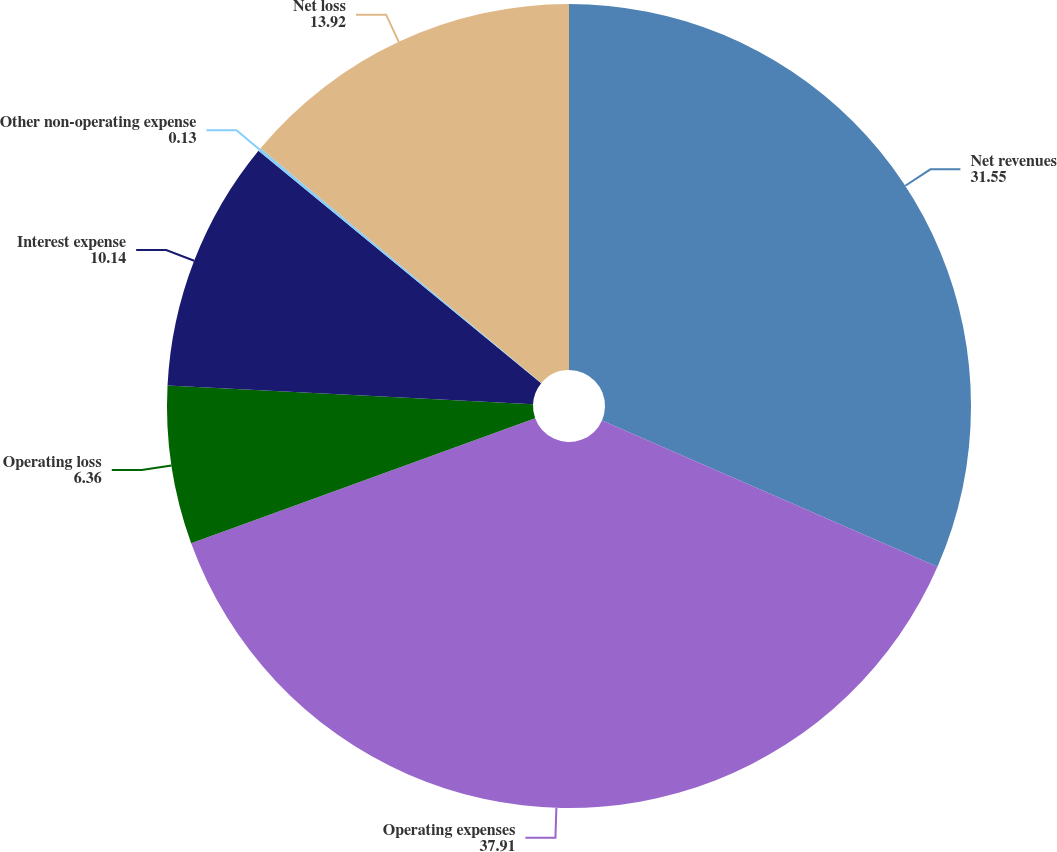Convert chart. <chart><loc_0><loc_0><loc_500><loc_500><pie_chart><fcel>Net revenues<fcel>Operating expenses<fcel>Operating loss<fcel>Interest expense<fcel>Other non-operating expense<fcel>Net loss<nl><fcel>31.55%<fcel>37.91%<fcel>6.36%<fcel>10.14%<fcel>0.13%<fcel>13.92%<nl></chart> 